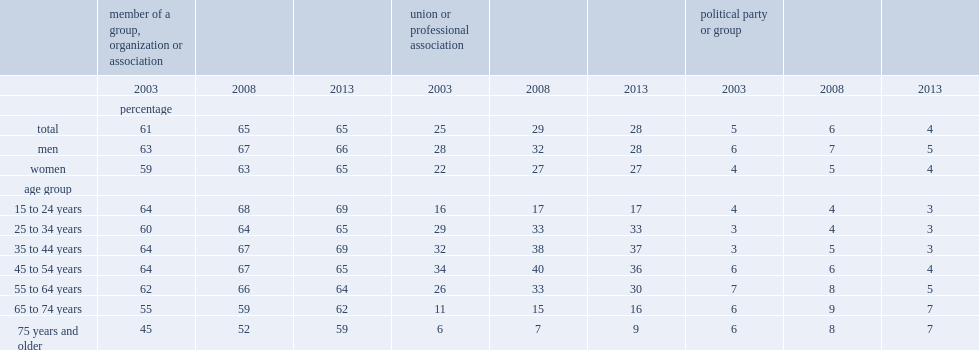I'm looking to parse the entire table for insights. Could you assist me with that? {'header': ['', 'member of a group, organization or association', '', '', 'union or professional association', '', '', 'political party or group', '', ''], 'rows': [['', '2003', '2008', '2013', '2003', '2008', '2013', '2003', '2008', '2013'], ['', 'percentage', '', '', '', '', '', '', '', ''], ['total', '61', '65', '65', '25', '29', '28', '5', '6', '4'], ['men', '63', '67', '66', '28', '32', '28', '6', '7', '5'], ['women', '59', '63', '65', '22', '27', '27', '4', '5', '4'], ['age group', '', '', '', '', '', '', '', '', ''], ['15 to 24 years', '64', '68', '69', '16', '17', '17', '4', '4', '3'], ['25 to 34 years', '60', '64', '65', '29', '33', '33', '3', '4', '3'], ['35 to 44 years', '64', '67', '69', '32', '38', '37', '3', '5', '3'], ['45 to 54 years', '64', '67', '65', '34', '40', '36', '6', '6', '4'], ['55 to 64 years', '62', '66', '64', '26', '33', '30', '7', '8', '5'], ['65 to 74 years', '55', '59', '62', '11', '15', '16', '6', '9', '7'], ['75 years and older', '45', '52', '59', '6', '7', '9', '6', '8', '7']]} In 2013, what was the percent of canadians were members or participants in a group, organization or association? 65.0. In 2003, what was the percent of canadians were members or participants in a group, organization or association? 61.0. From 2003 to 2013, what was the increase in the rate of participation in groups for women? 6. From 2003 to 2013, what was the increase in the rate of participation in groups for men? 3. How many percentage points was the proportion of seniors aged 75 and over who were members or participants up between 2003 and 2013? 14. 